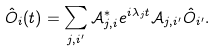Convert formula to latex. <formula><loc_0><loc_0><loc_500><loc_500>\hat { O } _ { i } ( t ) = \sum _ { j , i ^ { \prime } } \mathcal { A } ^ { * } _ { j , i } e ^ { i \lambda _ { j } t } \mathcal { A } _ { j , i ^ { \prime } } \hat { O } _ { i ^ { \prime } } .</formula> 